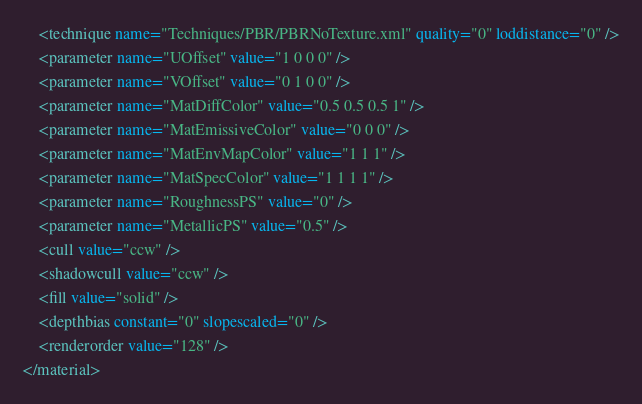<code> <loc_0><loc_0><loc_500><loc_500><_XML_>	<technique name="Techniques/PBR/PBRNoTexture.xml" quality="0" loddistance="0" />
	<parameter name="UOffset" value="1 0 0 0" />
	<parameter name="VOffset" value="0 1 0 0" />
	<parameter name="MatDiffColor" value="0.5 0.5 0.5 1" />
	<parameter name="MatEmissiveColor" value="0 0 0" />
	<parameter name="MatEnvMapColor" value="1 1 1" />
	<parameter name="MatSpecColor" value="1 1 1 1" />
	<parameter name="RoughnessPS" value="0" />
	<parameter name="MetallicPS" value="0.5" />
	<cull value="ccw" />
	<shadowcull value="ccw" />
	<fill value="solid" />
	<depthbias constant="0" slopescaled="0" />
	<renderorder value="128" />
</material>
</code> 